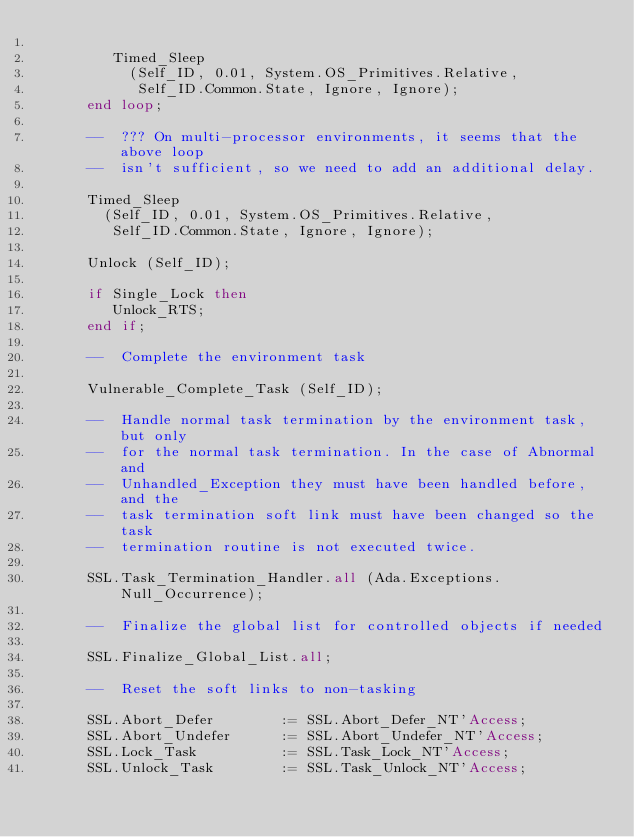Convert code to text. <code><loc_0><loc_0><loc_500><loc_500><_Ada_>
         Timed_Sleep
           (Self_ID, 0.01, System.OS_Primitives.Relative,
            Self_ID.Common.State, Ignore, Ignore);
      end loop;

      --  ??? On multi-processor environments, it seems that the above loop
      --  isn't sufficient, so we need to add an additional delay.

      Timed_Sleep
        (Self_ID, 0.01, System.OS_Primitives.Relative,
         Self_ID.Common.State, Ignore, Ignore);

      Unlock (Self_ID);

      if Single_Lock then
         Unlock_RTS;
      end if;

      --  Complete the environment task

      Vulnerable_Complete_Task (Self_ID);

      --  Handle normal task termination by the environment task, but only
      --  for the normal task termination. In the case of Abnormal and
      --  Unhandled_Exception they must have been handled before, and the
      --  task termination soft link must have been changed so the task
      --  termination routine is not executed twice.

      SSL.Task_Termination_Handler.all (Ada.Exceptions.Null_Occurrence);

      --  Finalize the global list for controlled objects if needed

      SSL.Finalize_Global_List.all;

      --  Reset the soft links to non-tasking

      SSL.Abort_Defer        := SSL.Abort_Defer_NT'Access;
      SSL.Abort_Undefer      := SSL.Abort_Undefer_NT'Access;
      SSL.Lock_Task          := SSL.Task_Lock_NT'Access;
      SSL.Unlock_Task        := SSL.Task_Unlock_NT'Access;</code> 